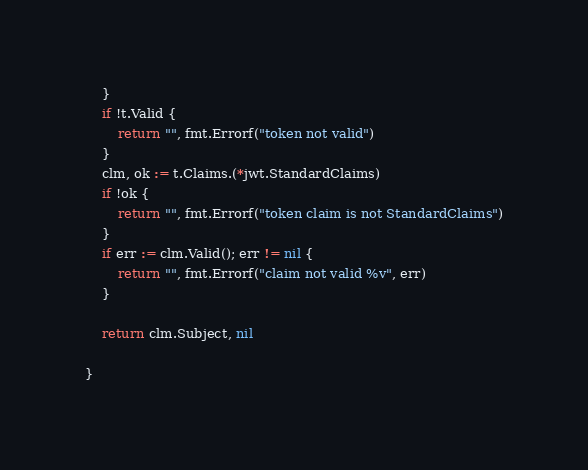<code> <loc_0><loc_0><loc_500><loc_500><_Go_>	}
	if !t.Valid {
		return "", fmt.Errorf("token not valid")
	}
	clm, ok := t.Claims.(*jwt.StandardClaims)
	if !ok {
		return "", fmt.Errorf("token claim is not StandardClaims")
	}
	if err := clm.Valid(); err != nil {
		return "", fmt.Errorf("claim not valid %v", err)
	}

	return clm.Subject, nil

}
</code> 